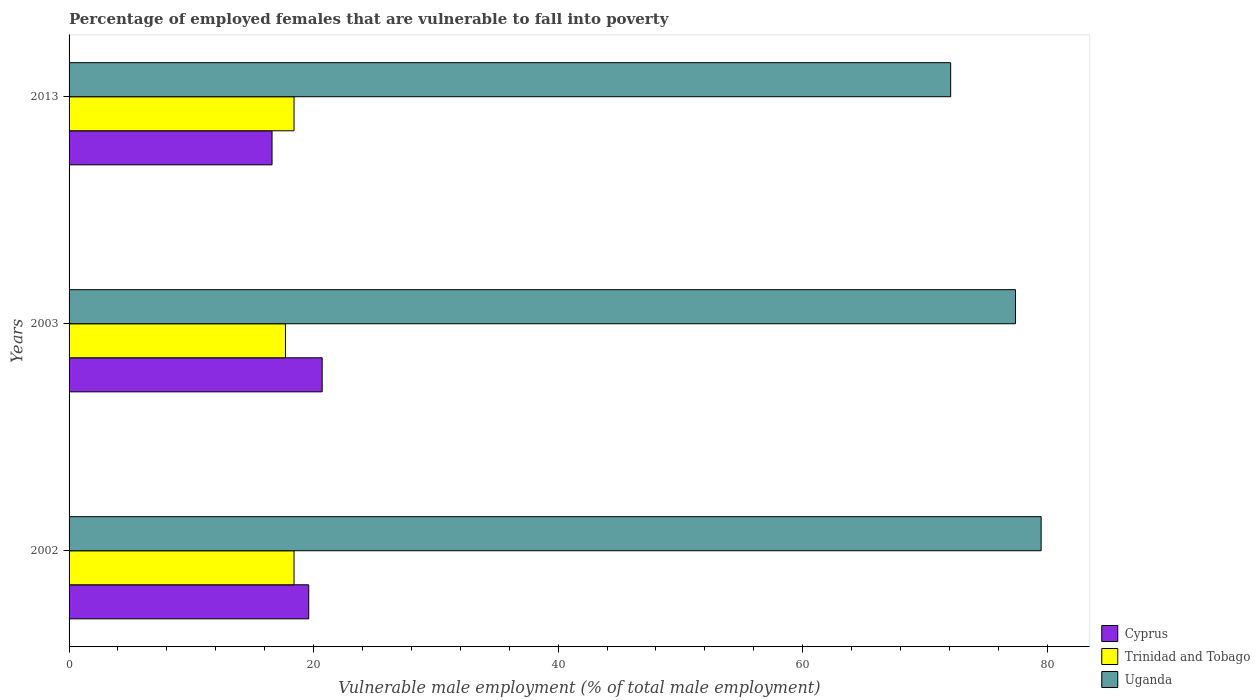How many different coloured bars are there?
Your answer should be very brief. 3. How many groups of bars are there?
Offer a very short reply. 3. How many bars are there on the 3rd tick from the top?
Ensure brevity in your answer.  3. In how many cases, is the number of bars for a given year not equal to the number of legend labels?
Make the answer very short. 0. What is the percentage of employed females who are vulnerable to fall into poverty in Uganda in 2002?
Provide a short and direct response. 79.5. Across all years, what is the maximum percentage of employed females who are vulnerable to fall into poverty in Uganda?
Provide a succinct answer. 79.5. Across all years, what is the minimum percentage of employed females who are vulnerable to fall into poverty in Uganda?
Offer a very short reply. 72.1. In which year was the percentage of employed females who are vulnerable to fall into poverty in Cyprus maximum?
Provide a succinct answer. 2003. In which year was the percentage of employed females who are vulnerable to fall into poverty in Cyprus minimum?
Provide a succinct answer. 2013. What is the total percentage of employed females who are vulnerable to fall into poverty in Uganda in the graph?
Provide a succinct answer. 229. What is the difference between the percentage of employed females who are vulnerable to fall into poverty in Uganda in 2002 and that in 2003?
Make the answer very short. 2.1. What is the difference between the percentage of employed females who are vulnerable to fall into poverty in Cyprus in 2013 and the percentage of employed females who are vulnerable to fall into poverty in Uganda in 2002?
Make the answer very short. -62.9. What is the average percentage of employed females who are vulnerable to fall into poverty in Uganda per year?
Make the answer very short. 76.33. In the year 2013, what is the difference between the percentage of employed females who are vulnerable to fall into poverty in Trinidad and Tobago and percentage of employed females who are vulnerable to fall into poverty in Uganda?
Ensure brevity in your answer.  -53.7. What is the ratio of the percentage of employed females who are vulnerable to fall into poverty in Cyprus in 2002 to that in 2013?
Offer a very short reply. 1.18. Is the percentage of employed females who are vulnerable to fall into poverty in Cyprus in 2002 less than that in 2013?
Provide a short and direct response. No. Is the difference between the percentage of employed females who are vulnerable to fall into poverty in Trinidad and Tobago in 2003 and 2013 greater than the difference between the percentage of employed females who are vulnerable to fall into poverty in Uganda in 2003 and 2013?
Your answer should be compact. No. What is the difference between the highest and the second highest percentage of employed females who are vulnerable to fall into poverty in Uganda?
Make the answer very short. 2.1. What is the difference between the highest and the lowest percentage of employed females who are vulnerable to fall into poverty in Cyprus?
Offer a terse response. 4.1. Is the sum of the percentage of employed females who are vulnerable to fall into poverty in Trinidad and Tobago in 2002 and 2003 greater than the maximum percentage of employed females who are vulnerable to fall into poverty in Uganda across all years?
Your answer should be compact. No. What does the 3rd bar from the top in 2002 represents?
Provide a succinct answer. Cyprus. What does the 3rd bar from the bottom in 2013 represents?
Your answer should be compact. Uganda. Is it the case that in every year, the sum of the percentage of employed females who are vulnerable to fall into poverty in Uganda and percentage of employed females who are vulnerable to fall into poverty in Cyprus is greater than the percentage of employed females who are vulnerable to fall into poverty in Trinidad and Tobago?
Offer a terse response. Yes. How many bars are there?
Make the answer very short. 9. How many years are there in the graph?
Provide a succinct answer. 3. What is the difference between two consecutive major ticks on the X-axis?
Make the answer very short. 20. How many legend labels are there?
Provide a succinct answer. 3. What is the title of the graph?
Provide a short and direct response. Percentage of employed females that are vulnerable to fall into poverty. What is the label or title of the X-axis?
Make the answer very short. Vulnerable male employment (% of total male employment). What is the label or title of the Y-axis?
Your answer should be compact. Years. What is the Vulnerable male employment (% of total male employment) of Cyprus in 2002?
Provide a succinct answer. 19.6. What is the Vulnerable male employment (% of total male employment) of Trinidad and Tobago in 2002?
Your answer should be compact. 18.4. What is the Vulnerable male employment (% of total male employment) in Uganda in 2002?
Give a very brief answer. 79.5. What is the Vulnerable male employment (% of total male employment) in Cyprus in 2003?
Give a very brief answer. 20.7. What is the Vulnerable male employment (% of total male employment) of Trinidad and Tobago in 2003?
Provide a short and direct response. 17.7. What is the Vulnerable male employment (% of total male employment) in Uganda in 2003?
Keep it short and to the point. 77.4. What is the Vulnerable male employment (% of total male employment) of Cyprus in 2013?
Provide a succinct answer. 16.6. What is the Vulnerable male employment (% of total male employment) in Trinidad and Tobago in 2013?
Your answer should be compact. 18.4. What is the Vulnerable male employment (% of total male employment) of Uganda in 2013?
Provide a short and direct response. 72.1. Across all years, what is the maximum Vulnerable male employment (% of total male employment) in Cyprus?
Offer a terse response. 20.7. Across all years, what is the maximum Vulnerable male employment (% of total male employment) in Trinidad and Tobago?
Your response must be concise. 18.4. Across all years, what is the maximum Vulnerable male employment (% of total male employment) in Uganda?
Provide a succinct answer. 79.5. Across all years, what is the minimum Vulnerable male employment (% of total male employment) of Cyprus?
Your answer should be compact. 16.6. Across all years, what is the minimum Vulnerable male employment (% of total male employment) in Trinidad and Tobago?
Offer a terse response. 17.7. Across all years, what is the minimum Vulnerable male employment (% of total male employment) in Uganda?
Give a very brief answer. 72.1. What is the total Vulnerable male employment (% of total male employment) in Cyprus in the graph?
Your answer should be compact. 56.9. What is the total Vulnerable male employment (% of total male employment) of Trinidad and Tobago in the graph?
Provide a succinct answer. 54.5. What is the total Vulnerable male employment (% of total male employment) in Uganda in the graph?
Make the answer very short. 229. What is the difference between the Vulnerable male employment (% of total male employment) of Cyprus in 2002 and that in 2003?
Give a very brief answer. -1.1. What is the difference between the Vulnerable male employment (% of total male employment) in Trinidad and Tobago in 2002 and that in 2003?
Offer a very short reply. 0.7. What is the difference between the Vulnerable male employment (% of total male employment) of Cyprus in 2002 and that in 2013?
Provide a short and direct response. 3. What is the difference between the Vulnerable male employment (% of total male employment) of Trinidad and Tobago in 2002 and that in 2013?
Your answer should be very brief. 0. What is the difference between the Vulnerable male employment (% of total male employment) in Uganda in 2002 and that in 2013?
Ensure brevity in your answer.  7.4. What is the difference between the Vulnerable male employment (% of total male employment) of Trinidad and Tobago in 2003 and that in 2013?
Offer a very short reply. -0.7. What is the difference between the Vulnerable male employment (% of total male employment) of Uganda in 2003 and that in 2013?
Your answer should be very brief. 5.3. What is the difference between the Vulnerable male employment (% of total male employment) in Cyprus in 2002 and the Vulnerable male employment (% of total male employment) in Trinidad and Tobago in 2003?
Your response must be concise. 1.9. What is the difference between the Vulnerable male employment (% of total male employment) of Cyprus in 2002 and the Vulnerable male employment (% of total male employment) of Uganda in 2003?
Make the answer very short. -57.8. What is the difference between the Vulnerable male employment (% of total male employment) in Trinidad and Tobago in 2002 and the Vulnerable male employment (% of total male employment) in Uganda in 2003?
Make the answer very short. -59. What is the difference between the Vulnerable male employment (% of total male employment) in Cyprus in 2002 and the Vulnerable male employment (% of total male employment) in Trinidad and Tobago in 2013?
Ensure brevity in your answer.  1.2. What is the difference between the Vulnerable male employment (% of total male employment) of Cyprus in 2002 and the Vulnerable male employment (% of total male employment) of Uganda in 2013?
Provide a short and direct response. -52.5. What is the difference between the Vulnerable male employment (% of total male employment) in Trinidad and Tobago in 2002 and the Vulnerable male employment (% of total male employment) in Uganda in 2013?
Offer a terse response. -53.7. What is the difference between the Vulnerable male employment (% of total male employment) of Cyprus in 2003 and the Vulnerable male employment (% of total male employment) of Trinidad and Tobago in 2013?
Provide a succinct answer. 2.3. What is the difference between the Vulnerable male employment (% of total male employment) of Cyprus in 2003 and the Vulnerable male employment (% of total male employment) of Uganda in 2013?
Offer a very short reply. -51.4. What is the difference between the Vulnerable male employment (% of total male employment) of Trinidad and Tobago in 2003 and the Vulnerable male employment (% of total male employment) of Uganda in 2013?
Give a very brief answer. -54.4. What is the average Vulnerable male employment (% of total male employment) in Cyprus per year?
Offer a terse response. 18.97. What is the average Vulnerable male employment (% of total male employment) in Trinidad and Tobago per year?
Provide a short and direct response. 18.17. What is the average Vulnerable male employment (% of total male employment) in Uganda per year?
Provide a short and direct response. 76.33. In the year 2002, what is the difference between the Vulnerable male employment (% of total male employment) of Cyprus and Vulnerable male employment (% of total male employment) of Uganda?
Ensure brevity in your answer.  -59.9. In the year 2002, what is the difference between the Vulnerable male employment (% of total male employment) in Trinidad and Tobago and Vulnerable male employment (% of total male employment) in Uganda?
Make the answer very short. -61.1. In the year 2003, what is the difference between the Vulnerable male employment (% of total male employment) in Cyprus and Vulnerable male employment (% of total male employment) in Trinidad and Tobago?
Ensure brevity in your answer.  3. In the year 2003, what is the difference between the Vulnerable male employment (% of total male employment) in Cyprus and Vulnerable male employment (% of total male employment) in Uganda?
Your answer should be compact. -56.7. In the year 2003, what is the difference between the Vulnerable male employment (% of total male employment) of Trinidad and Tobago and Vulnerable male employment (% of total male employment) of Uganda?
Your answer should be very brief. -59.7. In the year 2013, what is the difference between the Vulnerable male employment (% of total male employment) in Cyprus and Vulnerable male employment (% of total male employment) in Uganda?
Give a very brief answer. -55.5. In the year 2013, what is the difference between the Vulnerable male employment (% of total male employment) in Trinidad and Tobago and Vulnerable male employment (% of total male employment) in Uganda?
Offer a terse response. -53.7. What is the ratio of the Vulnerable male employment (% of total male employment) in Cyprus in 2002 to that in 2003?
Ensure brevity in your answer.  0.95. What is the ratio of the Vulnerable male employment (% of total male employment) of Trinidad and Tobago in 2002 to that in 2003?
Your answer should be compact. 1.04. What is the ratio of the Vulnerable male employment (% of total male employment) in Uganda in 2002 to that in 2003?
Give a very brief answer. 1.03. What is the ratio of the Vulnerable male employment (% of total male employment) in Cyprus in 2002 to that in 2013?
Keep it short and to the point. 1.18. What is the ratio of the Vulnerable male employment (% of total male employment) in Trinidad and Tobago in 2002 to that in 2013?
Your answer should be compact. 1. What is the ratio of the Vulnerable male employment (% of total male employment) of Uganda in 2002 to that in 2013?
Make the answer very short. 1.1. What is the ratio of the Vulnerable male employment (% of total male employment) of Cyprus in 2003 to that in 2013?
Your response must be concise. 1.25. What is the ratio of the Vulnerable male employment (% of total male employment) in Uganda in 2003 to that in 2013?
Keep it short and to the point. 1.07. What is the difference between the highest and the second highest Vulnerable male employment (% of total male employment) of Trinidad and Tobago?
Provide a succinct answer. 0. What is the difference between the highest and the second highest Vulnerable male employment (% of total male employment) in Uganda?
Offer a terse response. 2.1. What is the difference between the highest and the lowest Vulnerable male employment (% of total male employment) of Trinidad and Tobago?
Offer a very short reply. 0.7. What is the difference between the highest and the lowest Vulnerable male employment (% of total male employment) of Uganda?
Ensure brevity in your answer.  7.4. 